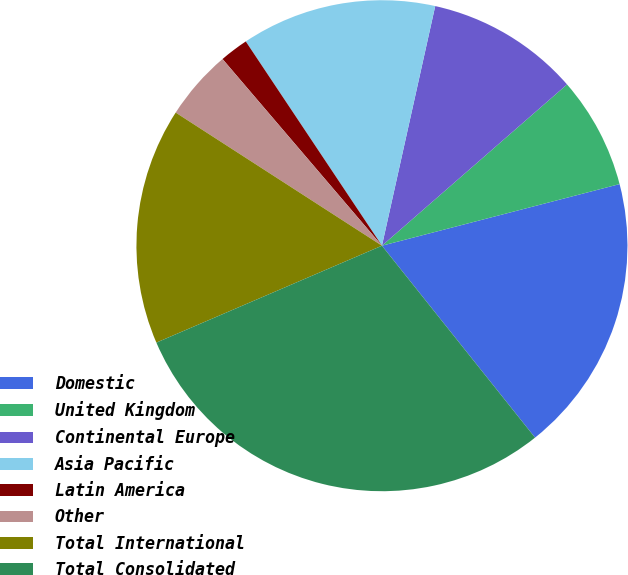Convert chart to OTSL. <chart><loc_0><loc_0><loc_500><loc_500><pie_chart><fcel>Domestic<fcel>United Kingdom<fcel>Continental Europe<fcel>Asia Pacific<fcel>Latin America<fcel>Other<fcel>Total International<fcel>Total Consolidated<nl><fcel>18.32%<fcel>7.37%<fcel>10.11%<fcel>12.84%<fcel>1.89%<fcel>4.63%<fcel>15.58%<fcel>29.26%<nl></chart> 